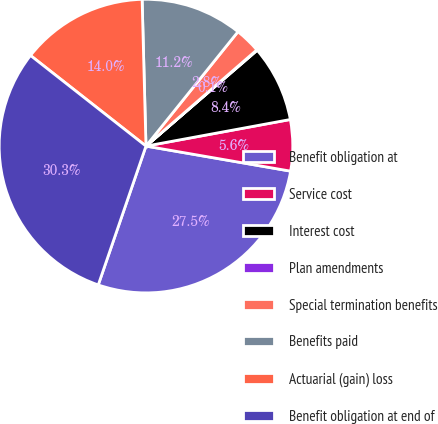Convert chart. <chart><loc_0><loc_0><loc_500><loc_500><pie_chart><fcel>Benefit obligation at<fcel>Service cost<fcel>Interest cost<fcel>Plan amendments<fcel>Special termination benefits<fcel>Benefits paid<fcel>Actuarial (gain) loss<fcel>Benefit obligation at end of<nl><fcel>27.54%<fcel>5.63%<fcel>8.42%<fcel>0.06%<fcel>2.84%<fcel>11.2%<fcel>13.99%<fcel>30.32%<nl></chart> 